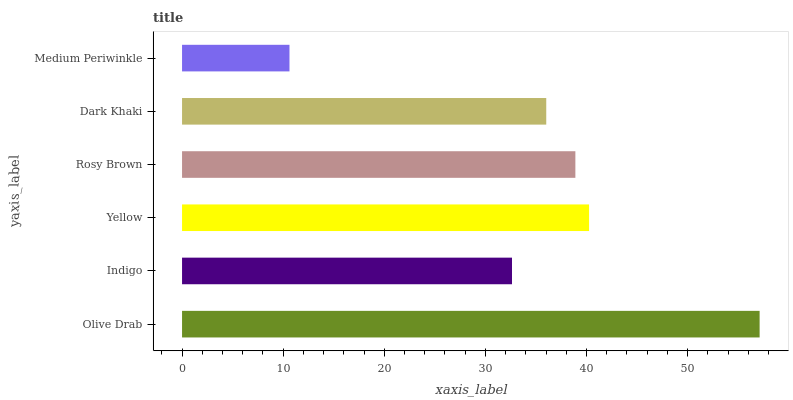Is Medium Periwinkle the minimum?
Answer yes or no. Yes. Is Olive Drab the maximum?
Answer yes or no. Yes. Is Indigo the minimum?
Answer yes or no. No. Is Indigo the maximum?
Answer yes or no. No. Is Olive Drab greater than Indigo?
Answer yes or no. Yes. Is Indigo less than Olive Drab?
Answer yes or no. Yes. Is Indigo greater than Olive Drab?
Answer yes or no. No. Is Olive Drab less than Indigo?
Answer yes or no. No. Is Rosy Brown the high median?
Answer yes or no. Yes. Is Dark Khaki the low median?
Answer yes or no. Yes. Is Olive Drab the high median?
Answer yes or no. No. Is Indigo the low median?
Answer yes or no. No. 